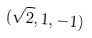Convert formula to latex. <formula><loc_0><loc_0><loc_500><loc_500>( \sqrt { 2 } , 1 , - 1 )</formula> 